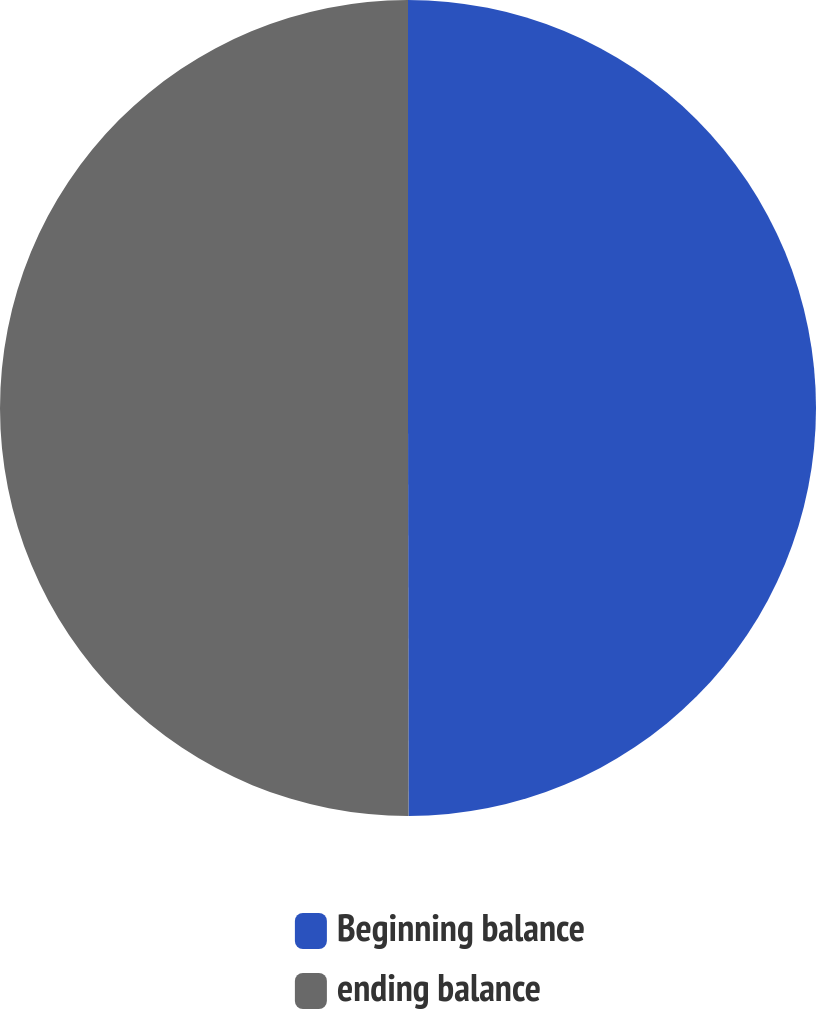<chart> <loc_0><loc_0><loc_500><loc_500><pie_chart><fcel>Beginning balance<fcel>ending balance<nl><fcel>49.98%<fcel>50.02%<nl></chart> 